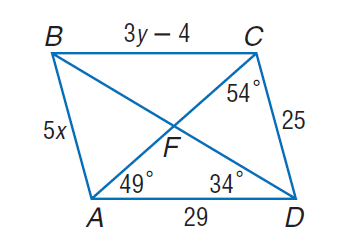Answer the mathemtical geometry problem and directly provide the correct option letter.
Question: Use parallelogram A B C D to find m \angle F B C.
Choices: A: 34 B: 43 C: 49 D: 53 A 